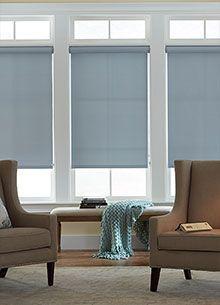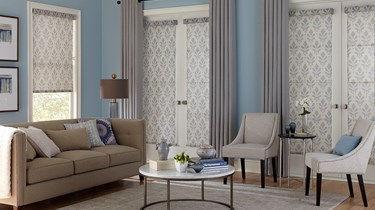The first image is the image on the left, the second image is the image on the right. Analyze the images presented: Is the assertion "One image is just a window, while the other is a room." valid? Answer yes or no. No. The first image is the image on the left, the second image is the image on the right. Examine the images to the left and right. Is the description "In at least one image there are three blue shades partly open." accurate? Answer yes or no. Yes. 